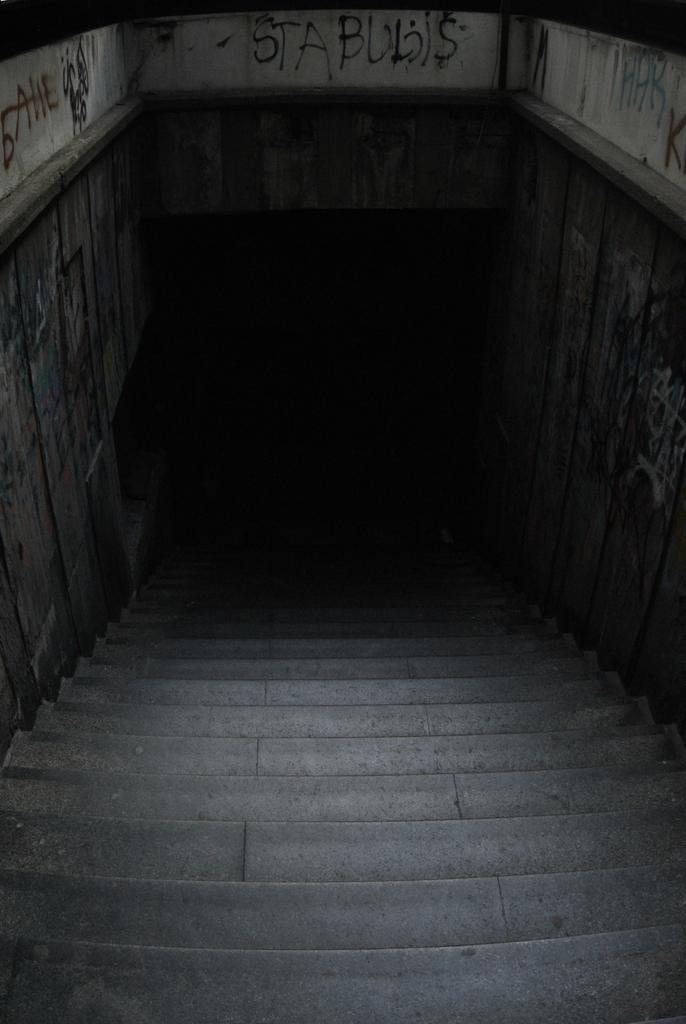What can be seen in the image that people use to move between different levels? There are stairs in the image that people use to move between different levels. What is written or displayed on the wall in the image? There are texts on the wall in the image. What type of thought is being expressed on the shelf in the image? There is no shelf present in the image, and therefore no thoughts can be expressed on it. 